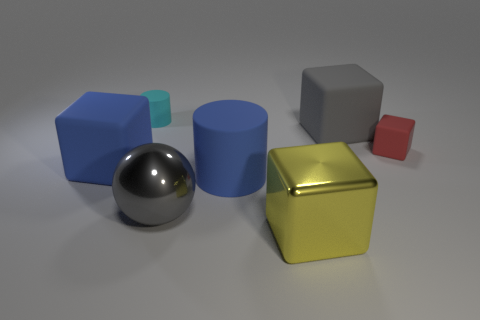Add 3 blue rubber cylinders. How many objects exist? 10 Subtract all spheres. How many objects are left? 6 Subtract 0 green cylinders. How many objects are left? 7 Subtract all yellow shiny blocks. Subtract all rubber objects. How many objects are left? 1 Add 7 cyan matte objects. How many cyan matte objects are left? 8 Add 1 shiny balls. How many shiny balls exist? 2 